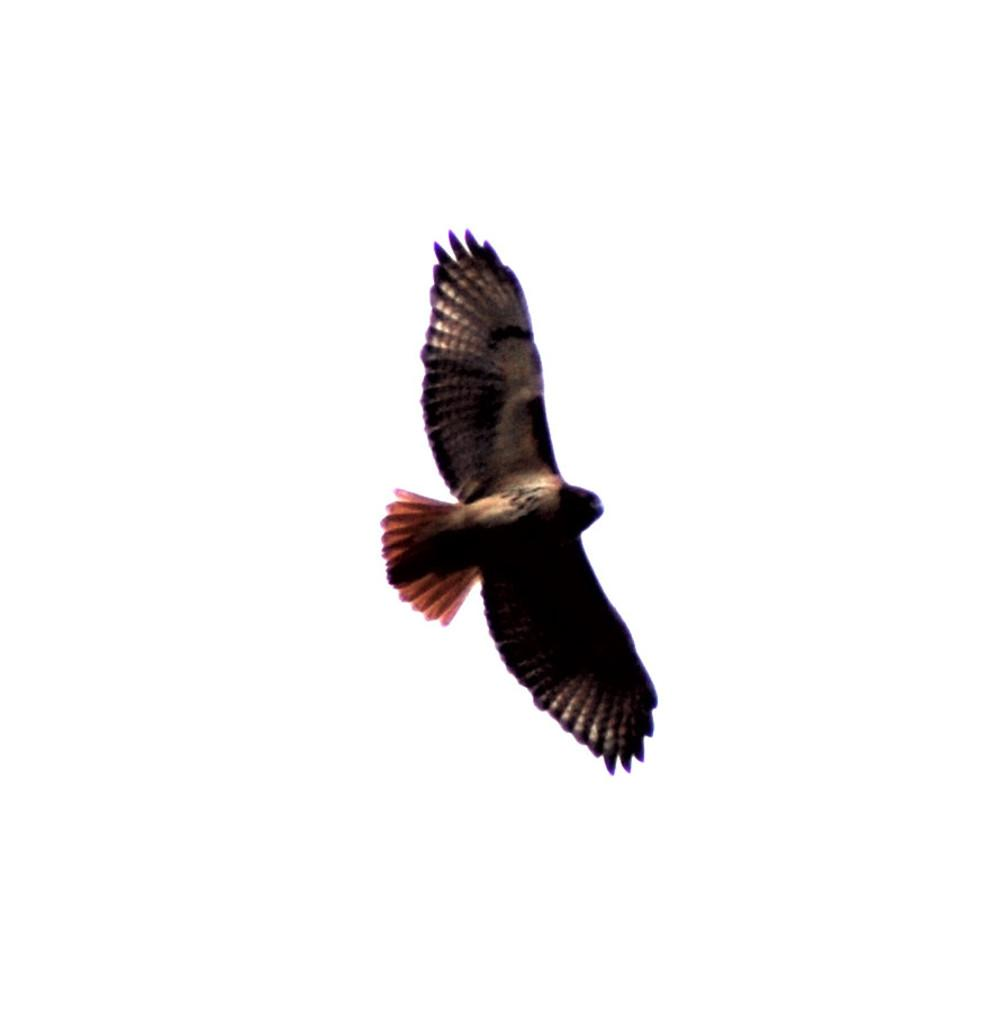What type of animal can be seen in the image? There is a bird in the image. What is the bird doing in the image? The bird is flying. What color is the bird in the image? The bird is brown in color. How does the bird use the hose in the image? There is no hose present in the image, so the bird cannot use a hose. 